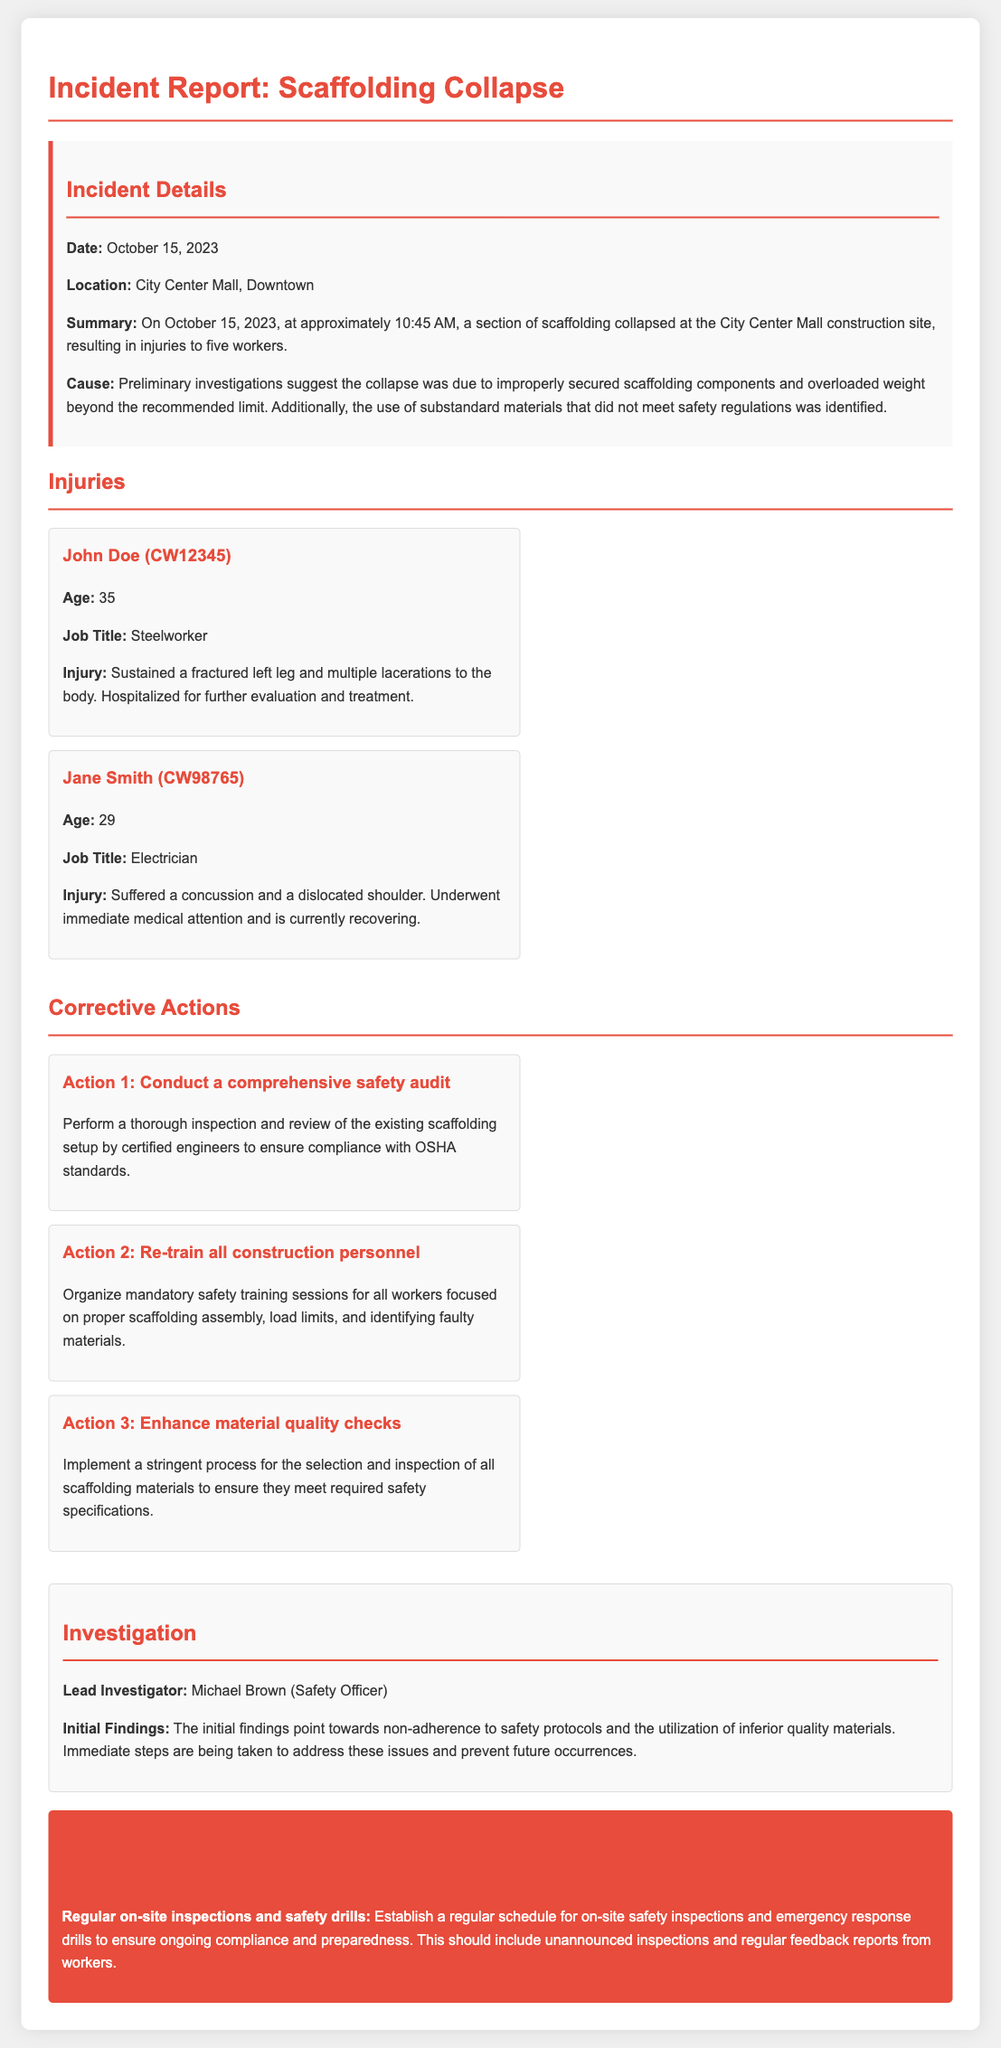What was the date of the incident? The date of the incident is clearly stated in the incident details section.
Answer: October 15, 2023 How many workers were injured in the collapse? The incident report mentions the number of injured workers in the summary of the incident.
Answer: Five What is the job title of John Doe? John Doe's job title is provided in the injuries section of the document.
Answer: Steelworker What injury did Jane Smith sustain? Jane Smith's injury is detailed in the injuries section.
Answer: Concussion and a dislocated shoulder Who is the lead investigator? The document specifies the lead investigator's name in the investigation section.
Answer: Michael Brown What was identified as a cause of the scaffolding collapse? The cause of the collapse is outlined in the incident details section.
Answer: Improperly secured scaffolding components What is one of the corrective actions? The corrective actions section lists multiple actions taken after the incident.
Answer: Conduct a comprehensive safety audit What is the recommended follow-up action? The follow-up action is specified in the corresponding section of the report.
Answer: Regular on-site inspections and safety drills 